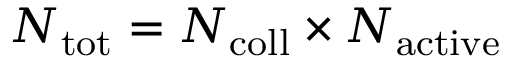<formula> <loc_0><loc_0><loc_500><loc_500>N _ { t o t } = N _ { c o l l } \times N _ { a c t i v e }</formula> 